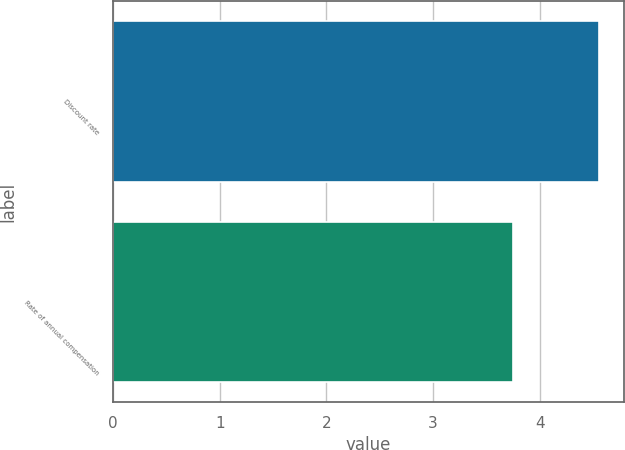<chart> <loc_0><loc_0><loc_500><loc_500><bar_chart><fcel>Discount rate<fcel>Rate of annual compensation<nl><fcel>4.56<fcel>3.75<nl></chart> 